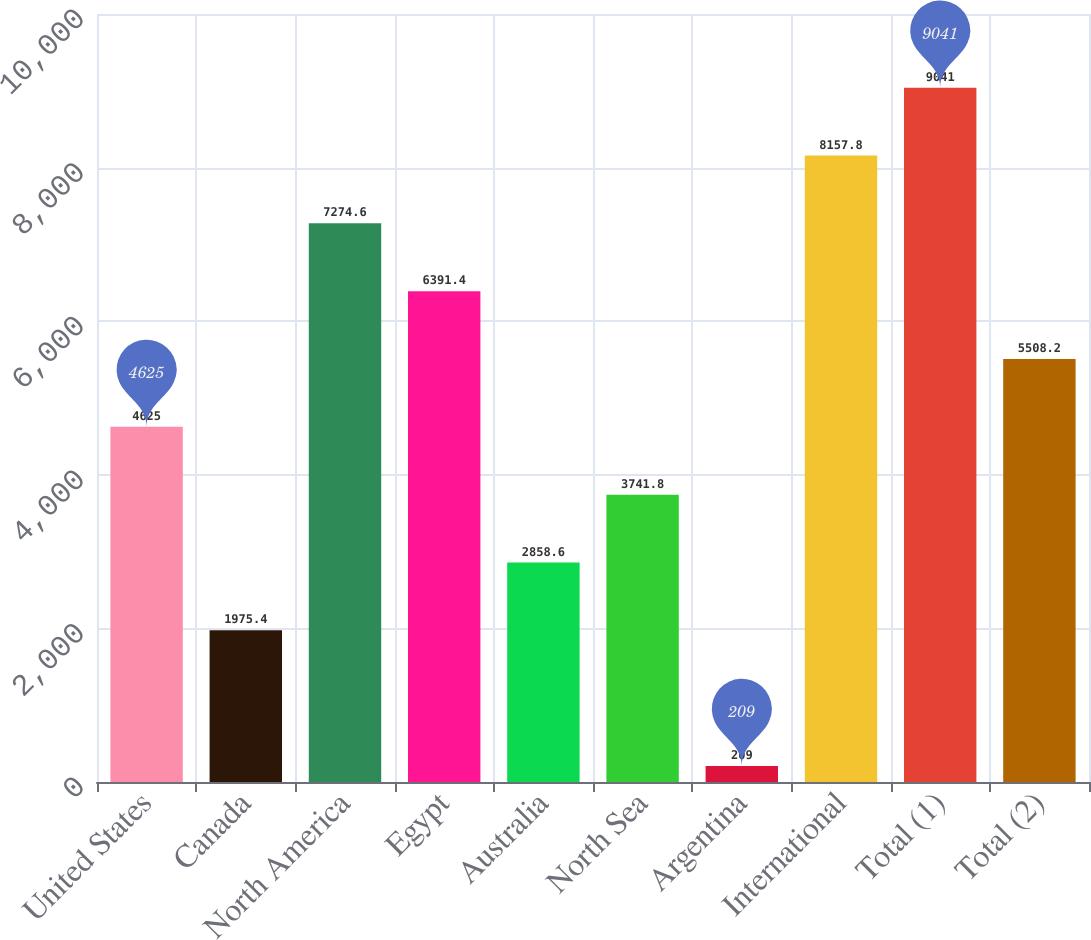<chart> <loc_0><loc_0><loc_500><loc_500><bar_chart><fcel>United States<fcel>Canada<fcel>North America<fcel>Egypt<fcel>Australia<fcel>North Sea<fcel>Argentina<fcel>International<fcel>Total (1)<fcel>Total (2)<nl><fcel>4625<fcel>1975.4<fcel>7274.6<fcel>6391.4<fcel>2858.6<fcel>3741.8<fcel>209<fcel>8157.8<fcel>9041<fcel>5508.2<nl></chart> 